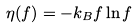Convert formula to latex. <formula><loc_0><loc_0><loc_500><loc_500>\eta ( f ) = - k _ { B } f \ln f</formula> 